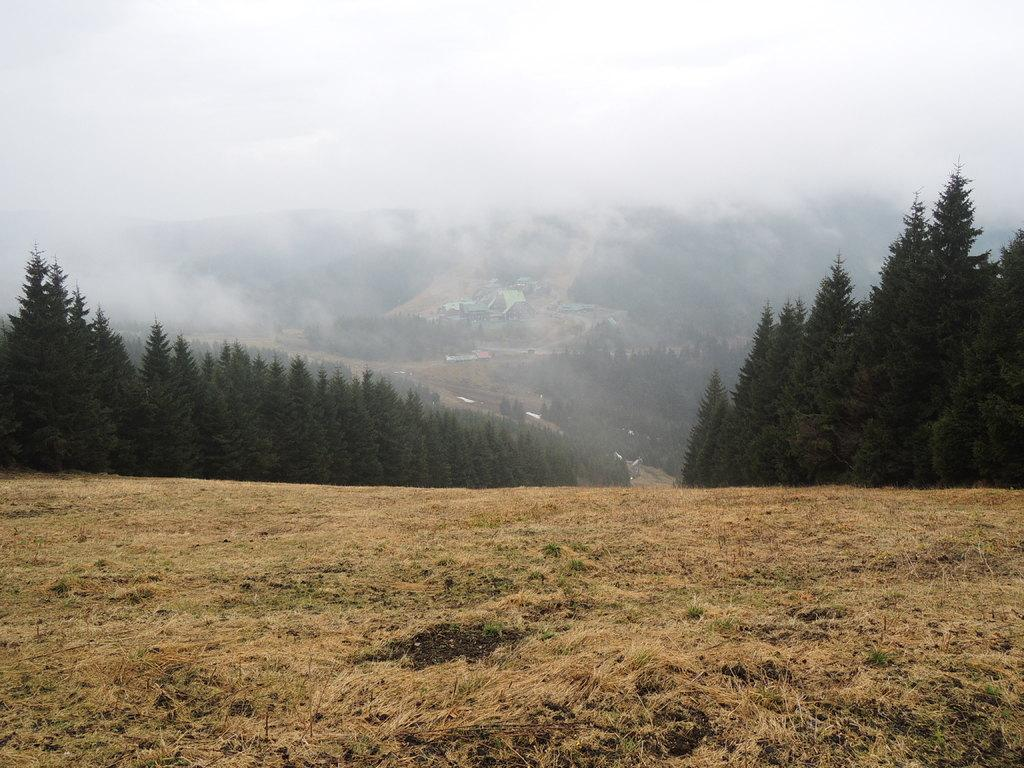What type of vegetation can be seen in the image? There are trees in the image. What geographical feature is present in the image? There are hills in the image. What is visible in the sky in the image? The sky is visible in the image. What type of weather is depicted in the image? There is snow in the image, indicating cold weather. What type of ground cover is present at the bottom of the image? There is grass at the bottom of the image. Can you see any quicksand in the image? There is no quicksand present in the image. What type of creature is flying through the sky in the image? There is no creature flying through the sky in the image. 